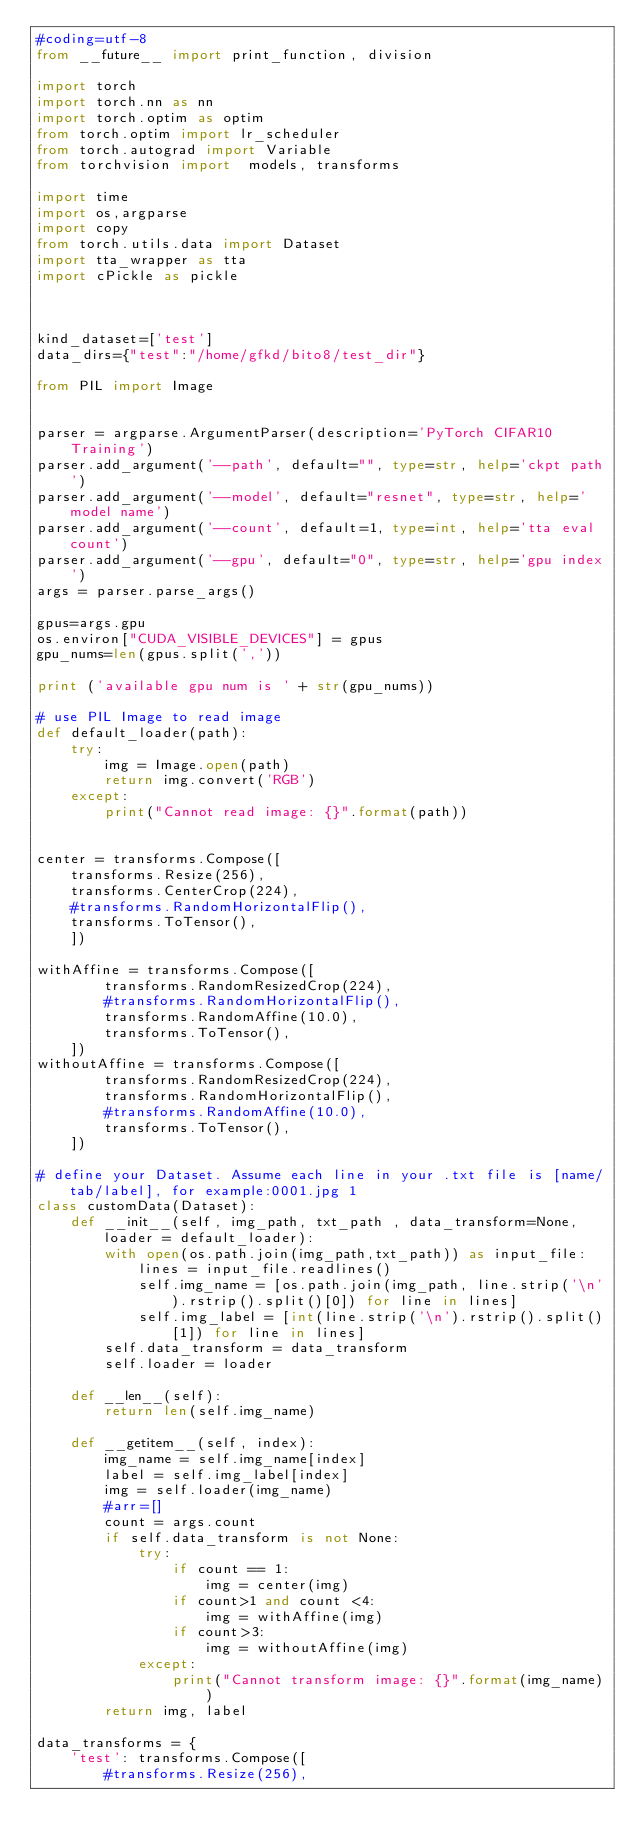Convert code to text. <code><loc_0><loc_0><loc_500><loc_500><_Python_>#coding=utf-8
from __future__ import print_function, division

import torch
import torch.nn as nn
import torch.optim as optim
from torch.optim import lr_scheduler
from torch.autograd import Variable
from torchvision import  models, transforms

import time
import os,argparse
import copy
from torch.utils.data import Dataset
import tta_wrapper as tta
import cPickle as pickle



kind_dataset=['test']
data_dirs={"test":"/home/gfkd/bito8/test_dir"}

from PIL import Image


parser = argparse.ArgumentParser(description='PyTorch CIFAR10 Training')
parser.add_argument('--path', default="", type=str, help='ckpt path')
parser.add_argument('--model', default="resnet", type=str, help='model name')
parser.add_argument('--count', default=1, type=int, help='tta eval count')
parser.add_argument('--gpu', default="0", type=str, help='gpu index')
args = parser.parse_args()

gpus=args.gpu
os.environ["CUDA_VISIBLE_DEVICES"] = gpus
gpu_nums=len(gpus.split(','))

print ('available gpu num is ' + str(gpu_nums))

# use PIL Image to read image
def default_loader(path):
    try:
        img = Image.open(path)
        return img.convert('RGB')
    except:
        print("Cannot read image: {}".format(path))


center = transforms.Compose([
    transforms.Resize(256),
    transforms.CenterCrop(224),
    #transforms.RandomHorizontalFlip(),
    transforms.ToTensor(),
    ])

withAffine = transforms.Compose([
        transforms.RandomResizedCrop(224),
        #transforms.RandomHorizontalFlip(),
        transforms.RandomAffine(10.0),
        transforms.ToTensor(),
    ])
withoutAffine = transforms.Compose([
        transforms.RandomResizedCrop(224),
        transforms.RandomHorizontalFlip(),
        #transforms.RandomAffine(10.0),
        transforms.ToTensor(),
    ])

# define your Dataset. Assume each line in your .txt file is [name/tab/label], for example:0001.jpg 1
class customData(Dataset):
    def __init__(self, img_path, txt_path , data_transform=None, loader = default_loader):
        with open(os.path.join(img_path,txt_path)) as input_file:
            lines = input_file.readlines()
            self.img_name = [os.path.join(img_path, line.strip('\n').rstrip().split()[0]) for line in lines]
            self.img_label = [int(line.strip('\n').rstrip().split()[1]) for line in lines]
        self.data_transform = data_transform
        self.loader = loader

    def __len__(self):
        return len(self.img_name)

    def __getitem__(self, index):
        img_name = self.img_name[index]
        label = self.img_label[index]
        img = self.loader(img_name)
        #arr=[]
        count = args.count
        if self.data_transform is not None:
            try:
                if count == 1:
                    img = center(img) 
                if count>1 and count <4:
                    img = withAffine(img)
                if count>3:
                    img = withoutAffine(img)
            except:
                print("Cannot transform image: {}".format(img_name))
        return img, label

data_transforms = {
    'test': transforms.Compose([
        #transforms.Resize(256),</code> 